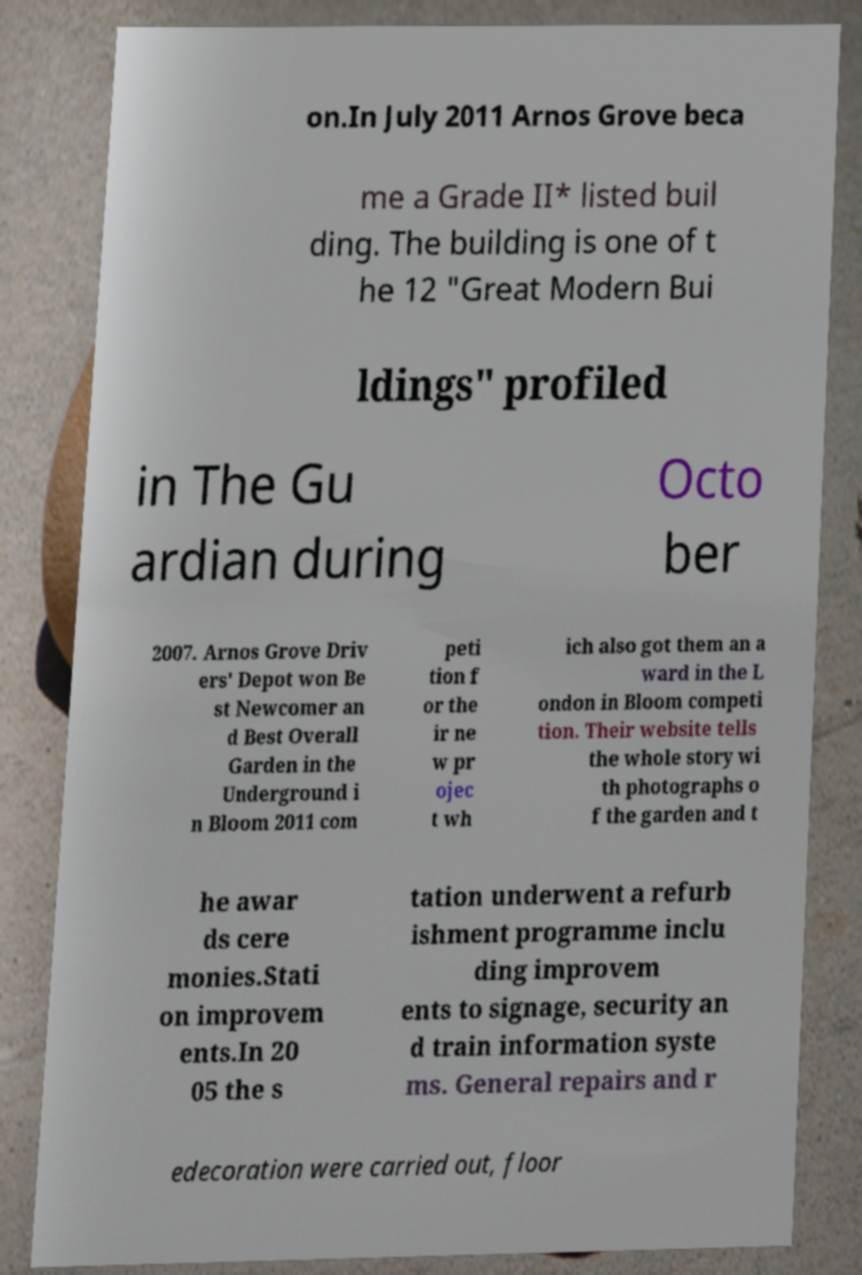For documentation purposes, I need the text within this image transcribed. Could you provide that? on.In July 2011 Arnos Grove beca me a Grade II* listed buil ding. The building is one of t he 12 "Great Modern Bui ldings" profiled in The Gu ardian during Octo ber 2007. Arnos Grove Driv ers' Depot won Be st Newcomer an d Best Overall Garden in the Underground i n Bloom 2011 com peti tion f or the ir ne w pr ojec t wh ich also got them an a ward in the L ondon in Bloom competi tion. Their website tells the whole story wi th photographs o f the garden and t he awar ds cere monies.Stati on improvem ents.In 20 05 the s tation underwent a refurb ishment programme inclu ding improvem ents to signage, security an d train information syste ms. General repairs and r edecoration were carried out, floor 